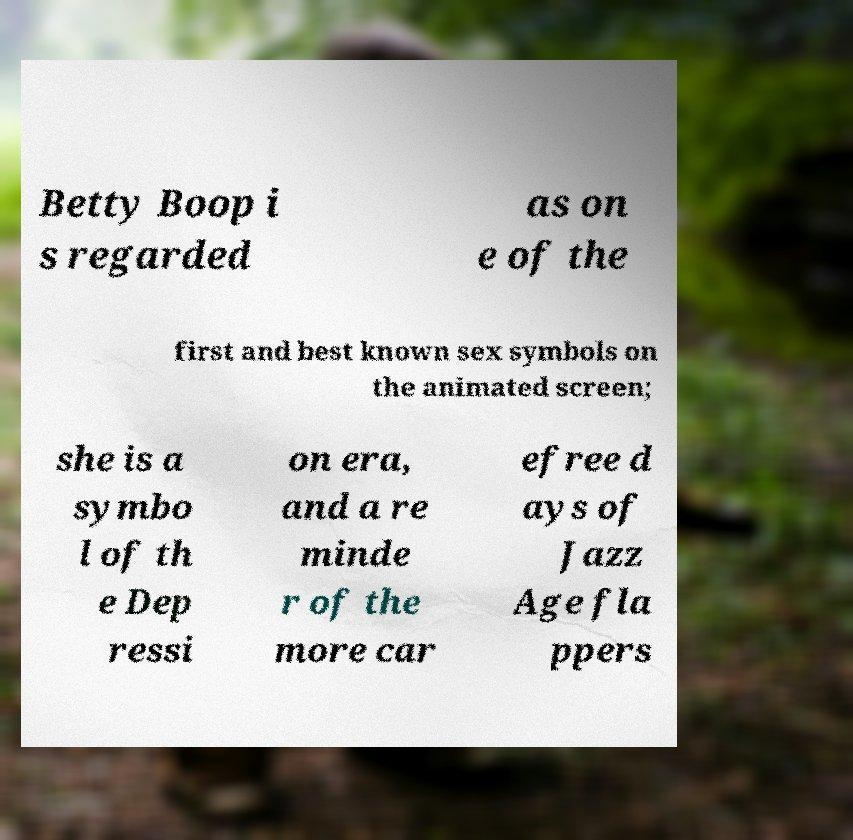Please read and relay the text visible in this image. What does it say? Betty Boop i s regarded as on e of the first and best known sex symbols on the animated screen; she is a symbo l of th e Dep ressi on era, and a re minde r of the more car efree d ays of Jazz Age fla ppers 